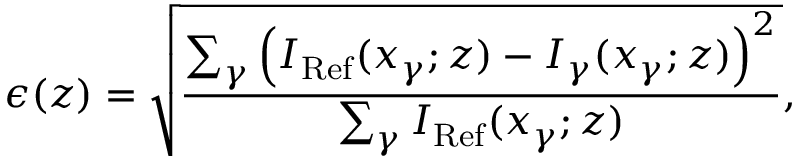Convert formula to latex. <formula><loc_0><loc_0><loc_500><loc_500>\epsilon ( z ) = \sqrt { \frac { \sum _ { \gamma } \left ( I _ { R e f } ( x _ { \gamma } ; z ) - I _ { \gamma } ( x _ { \gamma } ; z ) \right ) ^ { 2 } } { \sum _ { \gamma } I _ { R e f } ( x _ { \gamma } ; z ) } } ,</formula> 